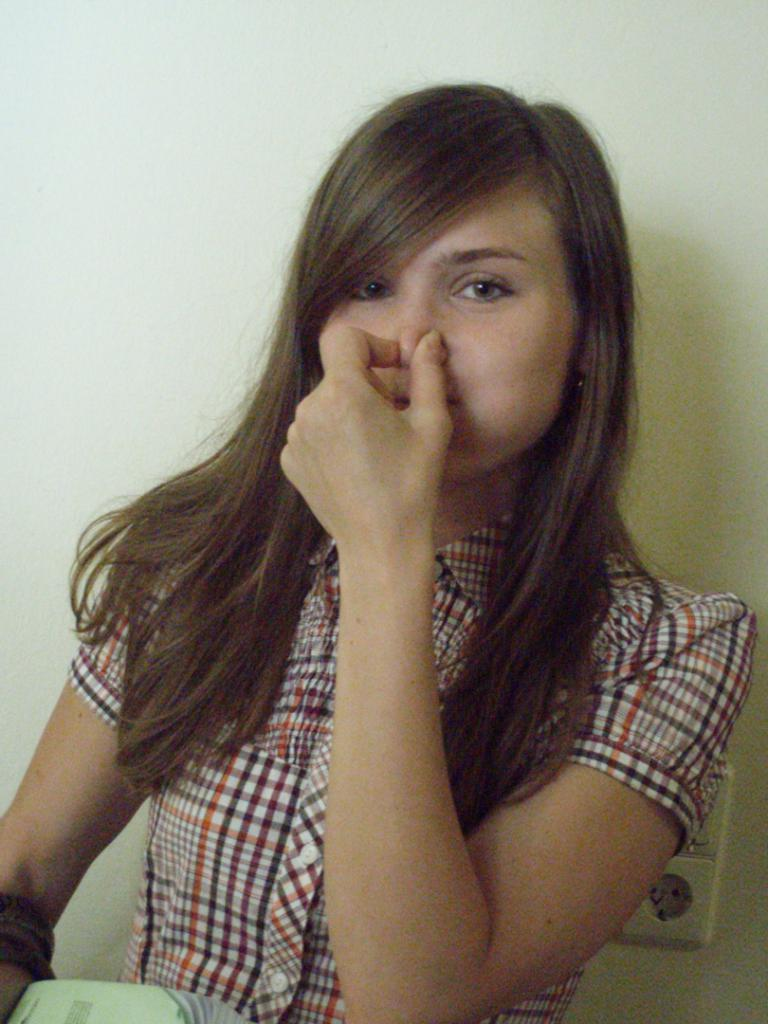Who is the main subject in the image? There is a woman in the image. What is the woman doing with her fingers? The woman is closing her nose with her two fingers. What can be seen behind the woman? There is a wall behind the woman. How many cats are sitting on the woman's lap in the image? There are no cats present in the image. What color is the orange that the woman is holding in the image? There is no orange present in the image. 